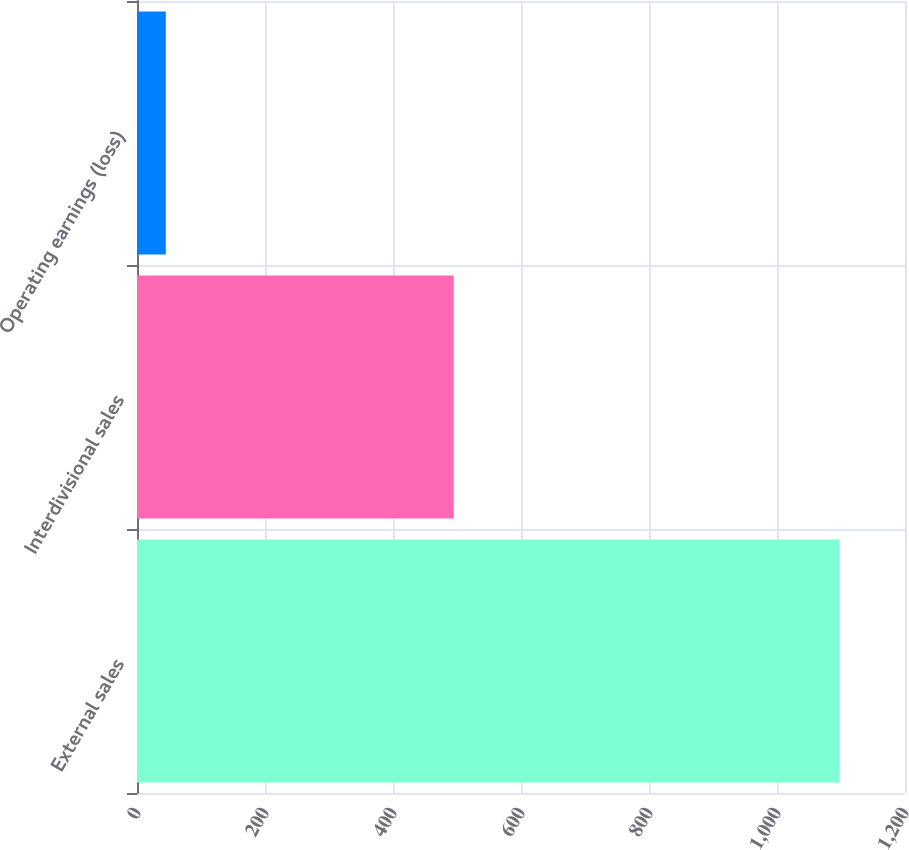Convert chart. <chart><loc_0><loc_0><loc_500><loc_500><bar_chart><fcel>External sales<fcel>Interdivisional sales<fcel>Operating earnings (loss)<nl><fcel>1098<fcel>495<fcel>45<nl></chart> 